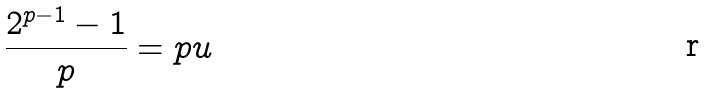Convert formula to latex. <formula><loc_0><loc_0><loc_500><loc_500>\frac { 2 ^ { p - 1 } - 1 } { p } = p u</formula> 